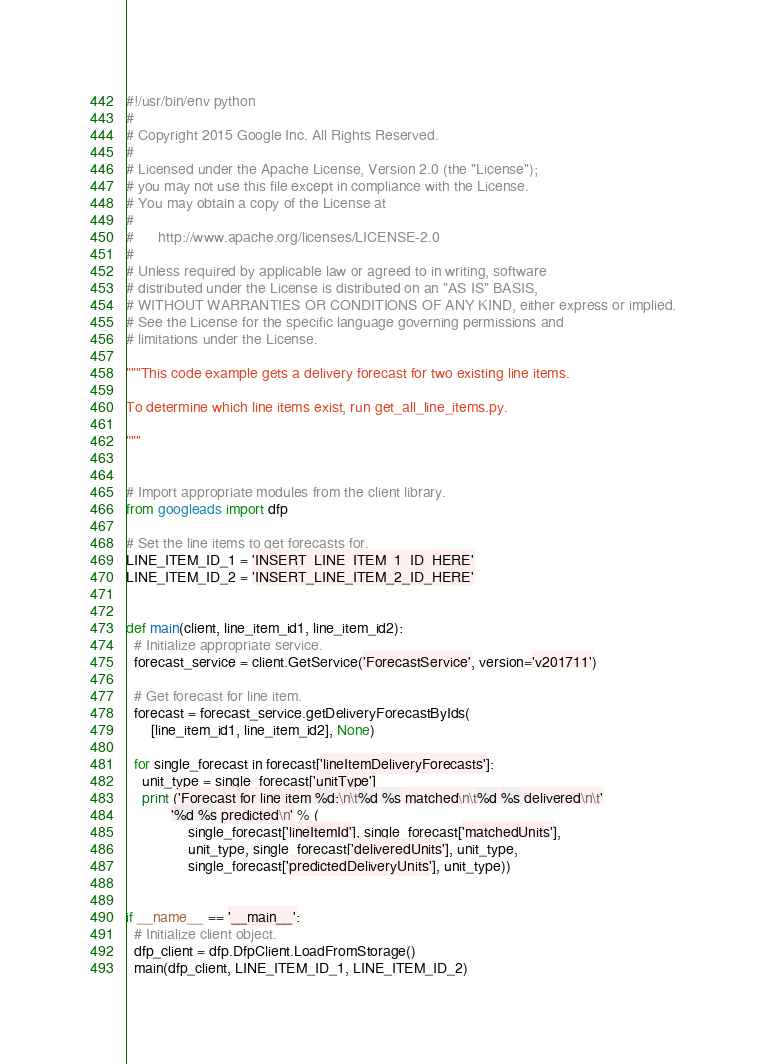Convert code to text. <code><loc_0><loc_0><loc_500><loc_500><_Python_>#!/usr/bin/env python
#
# Copyright 2015 Google Inc. All Rights Reserved.
#
# Licensed under the Apache License, Version 2.0 (the "License");
# you may not use this file except in compliance with the License.
# You may obtain a copy of the License at
#
#      http://www.apache.org/licenses/LICENSE-2.0
#
# Unless required by applicable law or agreed to in writing, software
# distributed under the License is distributed on an "AS IS" BASIS,
# WITHOUT WARRANTIES OR CONDITIONS OF ANY KIND, either express or implied.
# See the License for the specific language governing permissions and
# limitations under the License.

"""This code example gets a delivery forecast for two existing line items.

To determine which line items exist, run get_all_line_items.py.

"""


# Import appropriate modules from the client library.
from googleads import dfp

# Set the line items to get forecasts for.
LINE_ITEM_ID_1 = 'INSERT_LINE_ITEM_1_ID_HERE'
LINE_ITEM_ID_2 = 'INSERT_LINE_ITEM_2_ID_HERE'


def main(client, line_item_id1, line_item_id2):
  # Initialize appropriate service.
  forecast_service = client.GetService('ForecastService', version='v201711')

  # Get forecast for line item.
  forecast = forecast_service.getDeliveryForecastByIds(
      [line_item_id1, line_item_id2], None)

  for single_forecast in forecast['lineItemDeliveryForecasts']:
    unit_type = single_forecast['unitType']
    print ('Forecast for line item %d:\n\t%d %s matched\n\t%d %s delivered\n\t'
           '%d %s predicted\n' % (
               single_forecast['lineItemId'], single_forecast['matchedUnits'],
               unit_type, single_forecast['deliveredUnits'], unit_type,
               single_forecast['predictedDeliveryUnits'], unit_type))


if __name__ == '__main__':
  # Initialize client object.
  dfp_client = dfp.DfpClient.LoadFromStorage()
  main(dfp_client, LINE_ITEM_ID_1, LINE_ITEM_ID_2)
</code> 